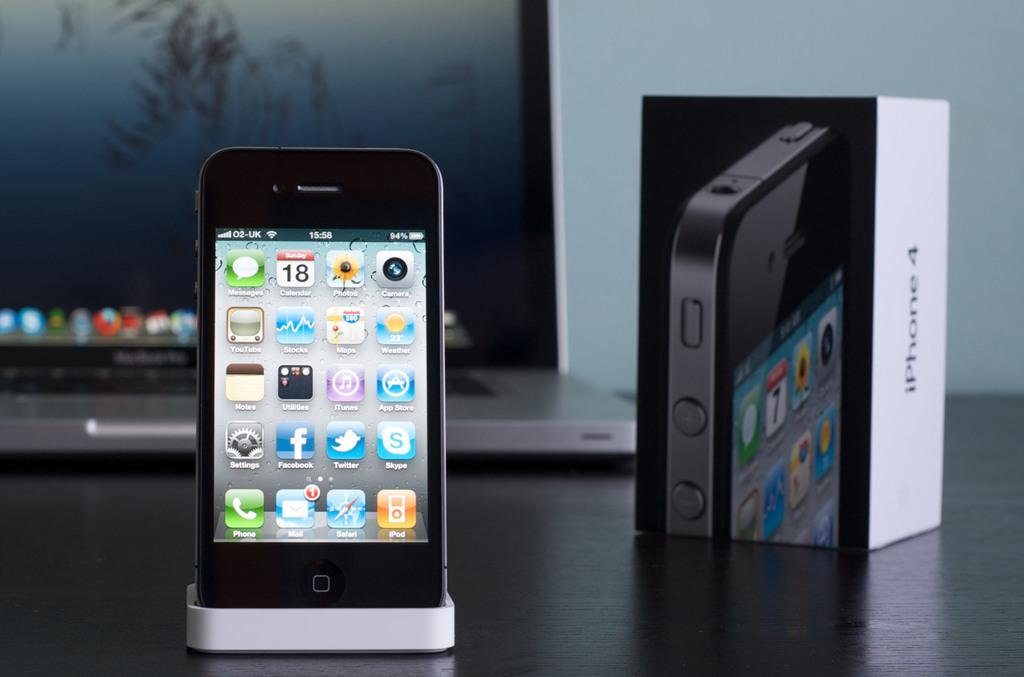<image>
Write a terse but informative summary of the picture. Iphone 4 is sitting on a port with a laptop and iphone box behind it 